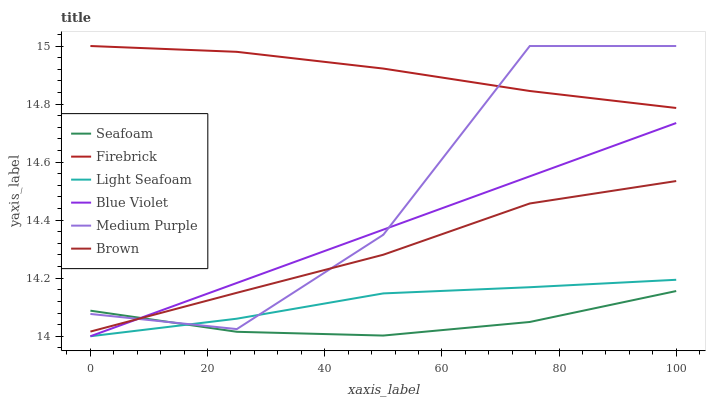Does Seafoam have the minimum area under the curve?
Answer yes or no. Yes. Does Firebrick have the maximum area under the curve?
Answer yes or no. Yes. Does Firebrick have the minimum area under the curve?
Answer yes or no. No. Does Seafoam have the maximum area under the curve?
Answer yes or no. No. Is Blue Violet the smoothest?
Answer yes or no. Yes. Is Medium Purple the roughest?
Answer yes or no. Yes. Is Firebrick the smoothest?
Answer yes or no. No. Is Firebrick the roughest?
Answer yes or no. No. Does Light Seafoam have the lowest value?
Answer yes or no. Yes. Does Seafoam have the lowest value?
Answer yes or no. No. Does Medium Purple have the highest value?
Answer yes or no. Yes. Does Seafoam have the highest value?
Answer yes or no. No. Is Light Seafoam less than Firebrick?
Answer yes or no. Yes. Is Firebrick greater than Brown?
Answer yes or no. Yes. Does Blue Violet intersect Seafoam?
Answer yes or no. Yes. Is Blue Violet less than Seafoam?
Answer yes or no. No. Is Blue Violet greater than Seafoam?
Answer yes or no. No. Does Light Seafoam intersect Firebrick?
Answer yes or no. No. 